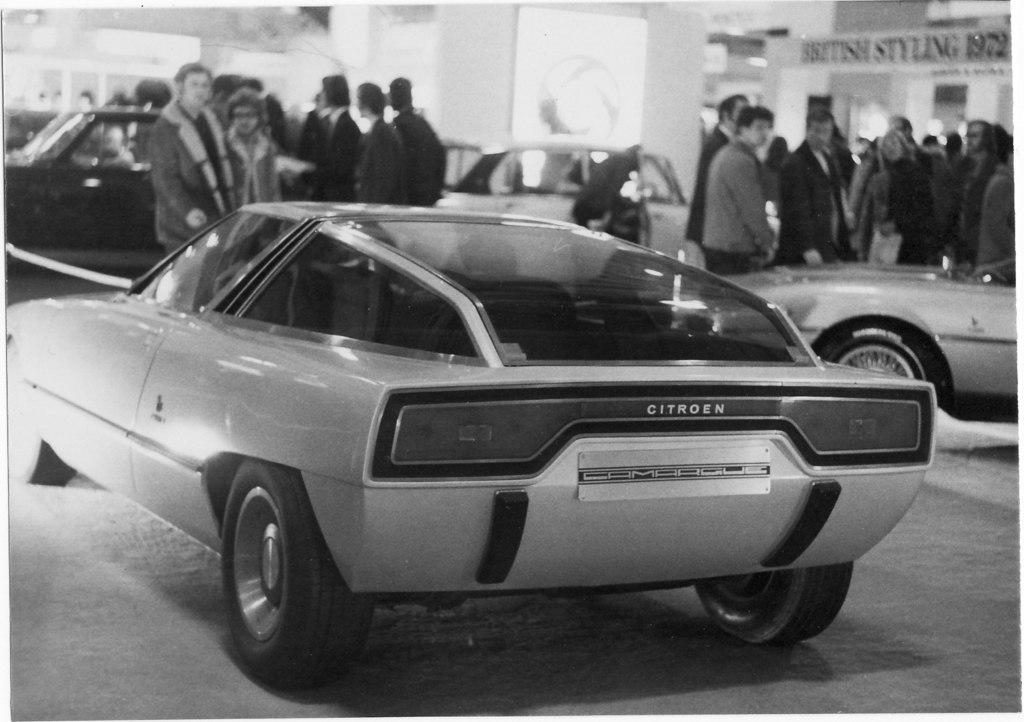What is the color scheme of the image? The image is black and white. What can be seen in the image besides the color scheme? There are people and vehicles in the image. Can you describe the background of the image? The background of the image is blurry. What else is visible in the background? There is a board visible in the background of the image. What type of card is being stamped in the image? There is no card or stamping activity present in the image. What songs are being sung by the people in the image? There is no indication of singing or any specific songs in the image. 